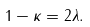<formula> <loc_0><loc_0><loc_500><loc_500>1 - \kappa = 2 \lambda .</formula> 